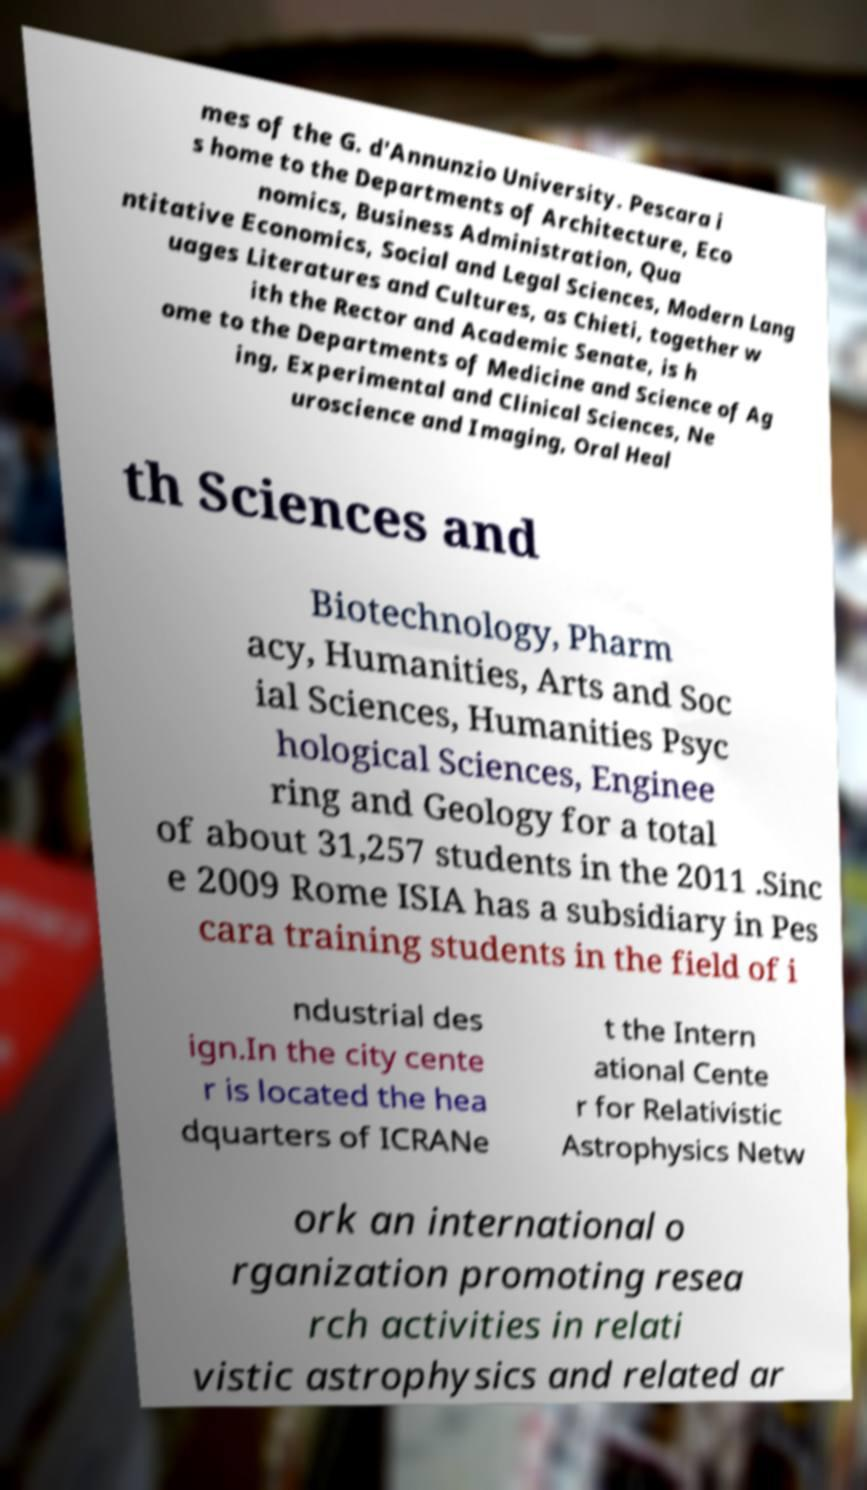There's text embedded in this image that I need extracted. Can you transcribe it verbatim? mes of the G. d'Annunzio University. Pescara i s home to the Departments of Architecture, Eco nomics, Business Administration, Qua ntitative Economics, Social and Legal Sciences, Modern Lang uages Literatures and Cultures, as Chieti, together w ith the Rector and Academic Senate, is h ome to the Departments of Medicine and Science of Ag ing, Experimental and Clinical Sciences, Ne uroscience and Imaging, Oral Heal th Sciences and Biotechnology, Pharm acy, Humanities, Arts and Soc ial Sciences, Humanities Psyc hological Sciences, Enginee ring and Geology for a total of about 31,257 students in the 2011 .Sinc e 2009 Rome ISIA has a subsidiary in Pes cara training students in the field of i ndustrial des ign.In the city cente r is located the hea dquarters of ICRANe t the Intern ational Cente r for Relativistic Astrophysics Netw ork an international o rganization promoting resea rch activities in relati vistic astrophysics and related ar 